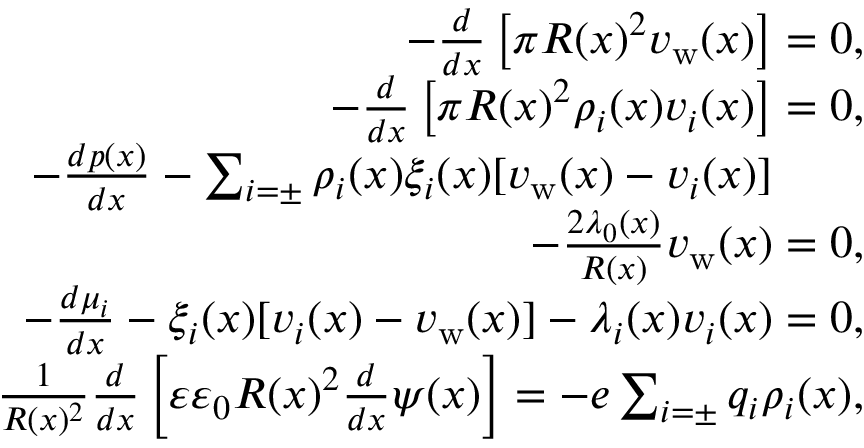<formula> <loc_0><loc_0><loc_500><loc_500>\begin{array} { r l r } { - \frac { d } { d x } \left [ \pi R ( x ) ^ { 2 } v _ { w } ( x ) \right ] = 0 , } \\ { - \frac { d } { d x } \left [ \pi R ( x ) ^ { 2 } \rho _ { i } ( x ) v _ { i } ( x ) \right ] = 0 , } \\ { - \frac { d p ( x ) } { d x } - \sum _ { i = \pm } \rho _ { i } ( x ) \xi _ { i } ( x ) [ v _ { w } ( x ) - v _ { i } ( x ) ] \quad } \\ { - \frac { 2 \lambda _ { 0 } ( x ) } { R ( x ) } v _ { w } ( x ) = 0 , } \\ { - \frac { d \mu _ { i } } { d x } - \xi _ { i } ( x ) [ v _ { i } ( x ) - v _ { w } ( x ) ] - \lambda _ { i } ( x ) v _ { i } ( x ) = 0 , } \\ { \frac { 1 } { R ( x ) ^ { 2 } } \frac { d } { d x } \left [ \varepsilon \varepsilon _ { 0 } R ( x ) ^ { 2 } \frac { d } { d x } \psi ( x ) \right ] = - e \sum _ { i = \pm } q _ { i } \rho _ { i } ( x ) , } \end{array}</formula> 